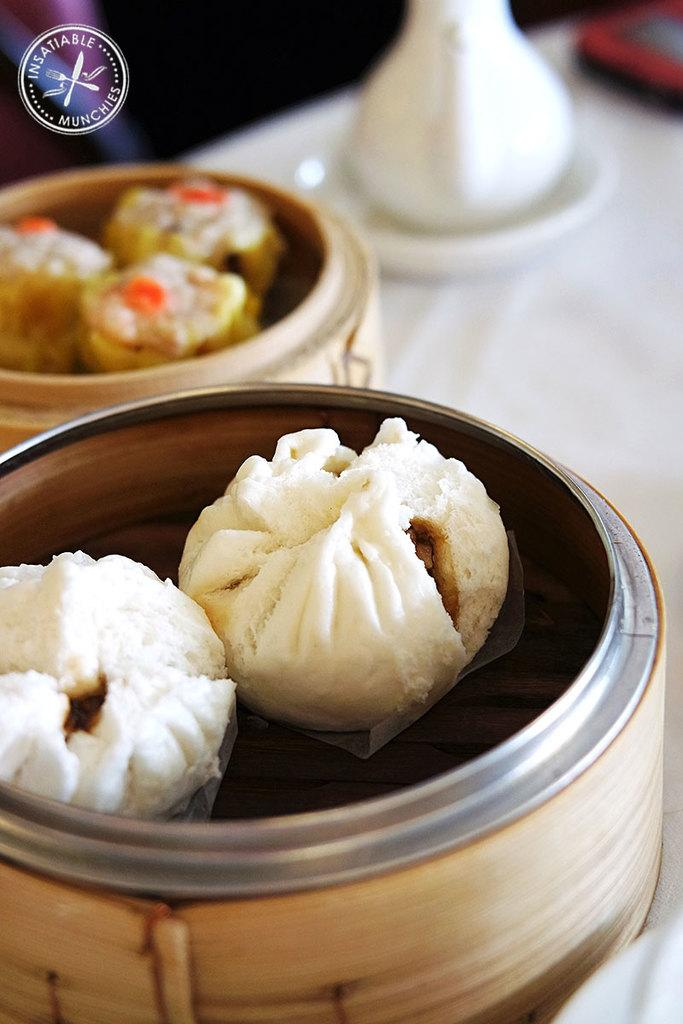Provide a one-sentence caption for the provided image. some dumplings in bamboo holders from a place called Insatiable Munchies. 